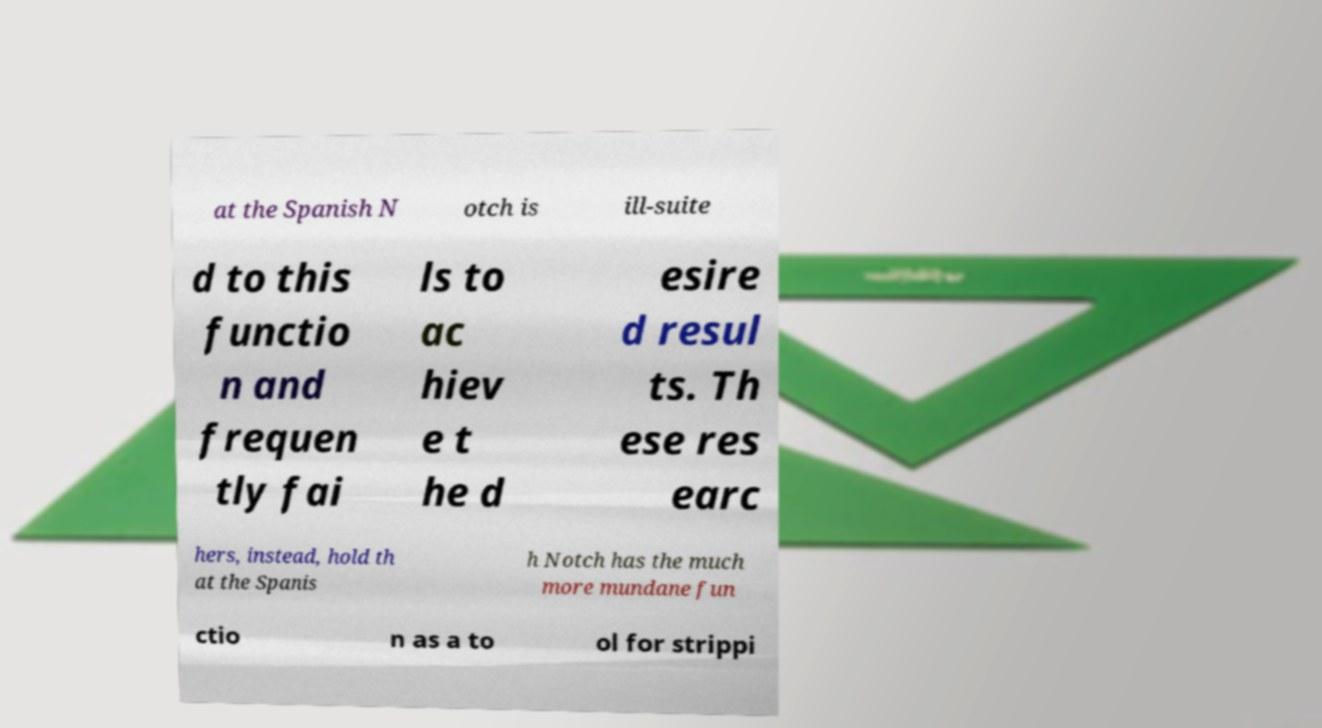Could you assist in decoding the text presented in this image and type it out clearly? at the Spanish N otch is ill-suite d to this functio n and frequen tly fai ls to ac hiev e t he d esire d resul ts. Th ese res earc hers, instead, hold th at the Spanis h Notch has the much more mundane fun ctio n as a to ol for strippi 